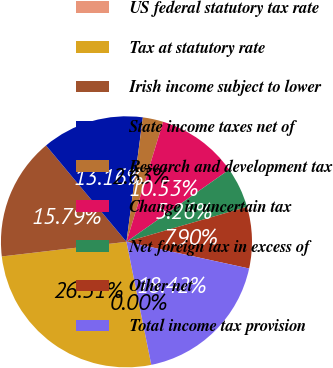<chart> <loc_0><loc_0><loc_500><loc_500><pie_chart><fcel>US federal statutory tax rate<fcel>Tax at statutory rate<fcel>Irish income subject to lower<fcel>State income taxes net of<fcel>Research and development tax<fcel>Change in uncertain tax<fcel>Net foreign tax in excess of<fcel>Other net<fcel>Total income tax provision<nl><fcel>0.0%<fcel>26.31%<fcel>15.79%<fcel>13.16%<fcel>2.63%<fcel>10.53%<fcel>5.26%<fcel>7.9%<fcel>18.42%<nl></chart> 